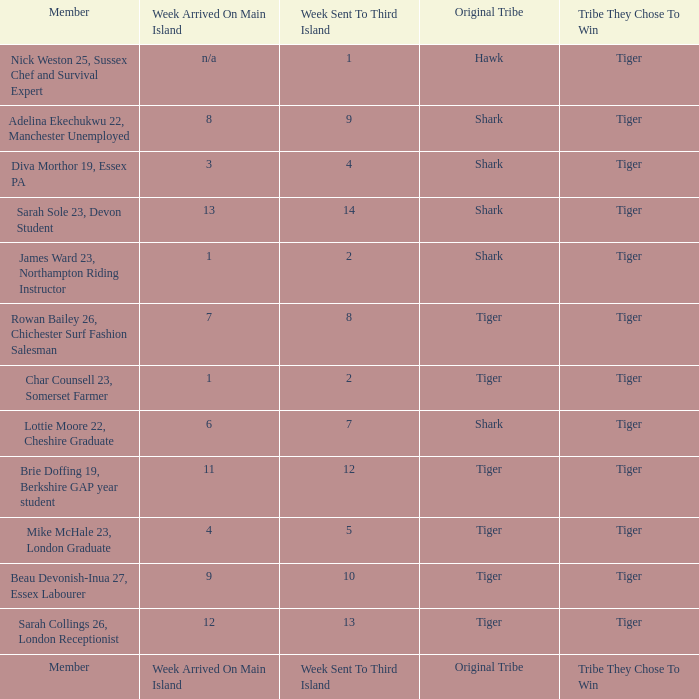What week was the member who arrived on the main island in week 6 sent to the third island? 7.0. 